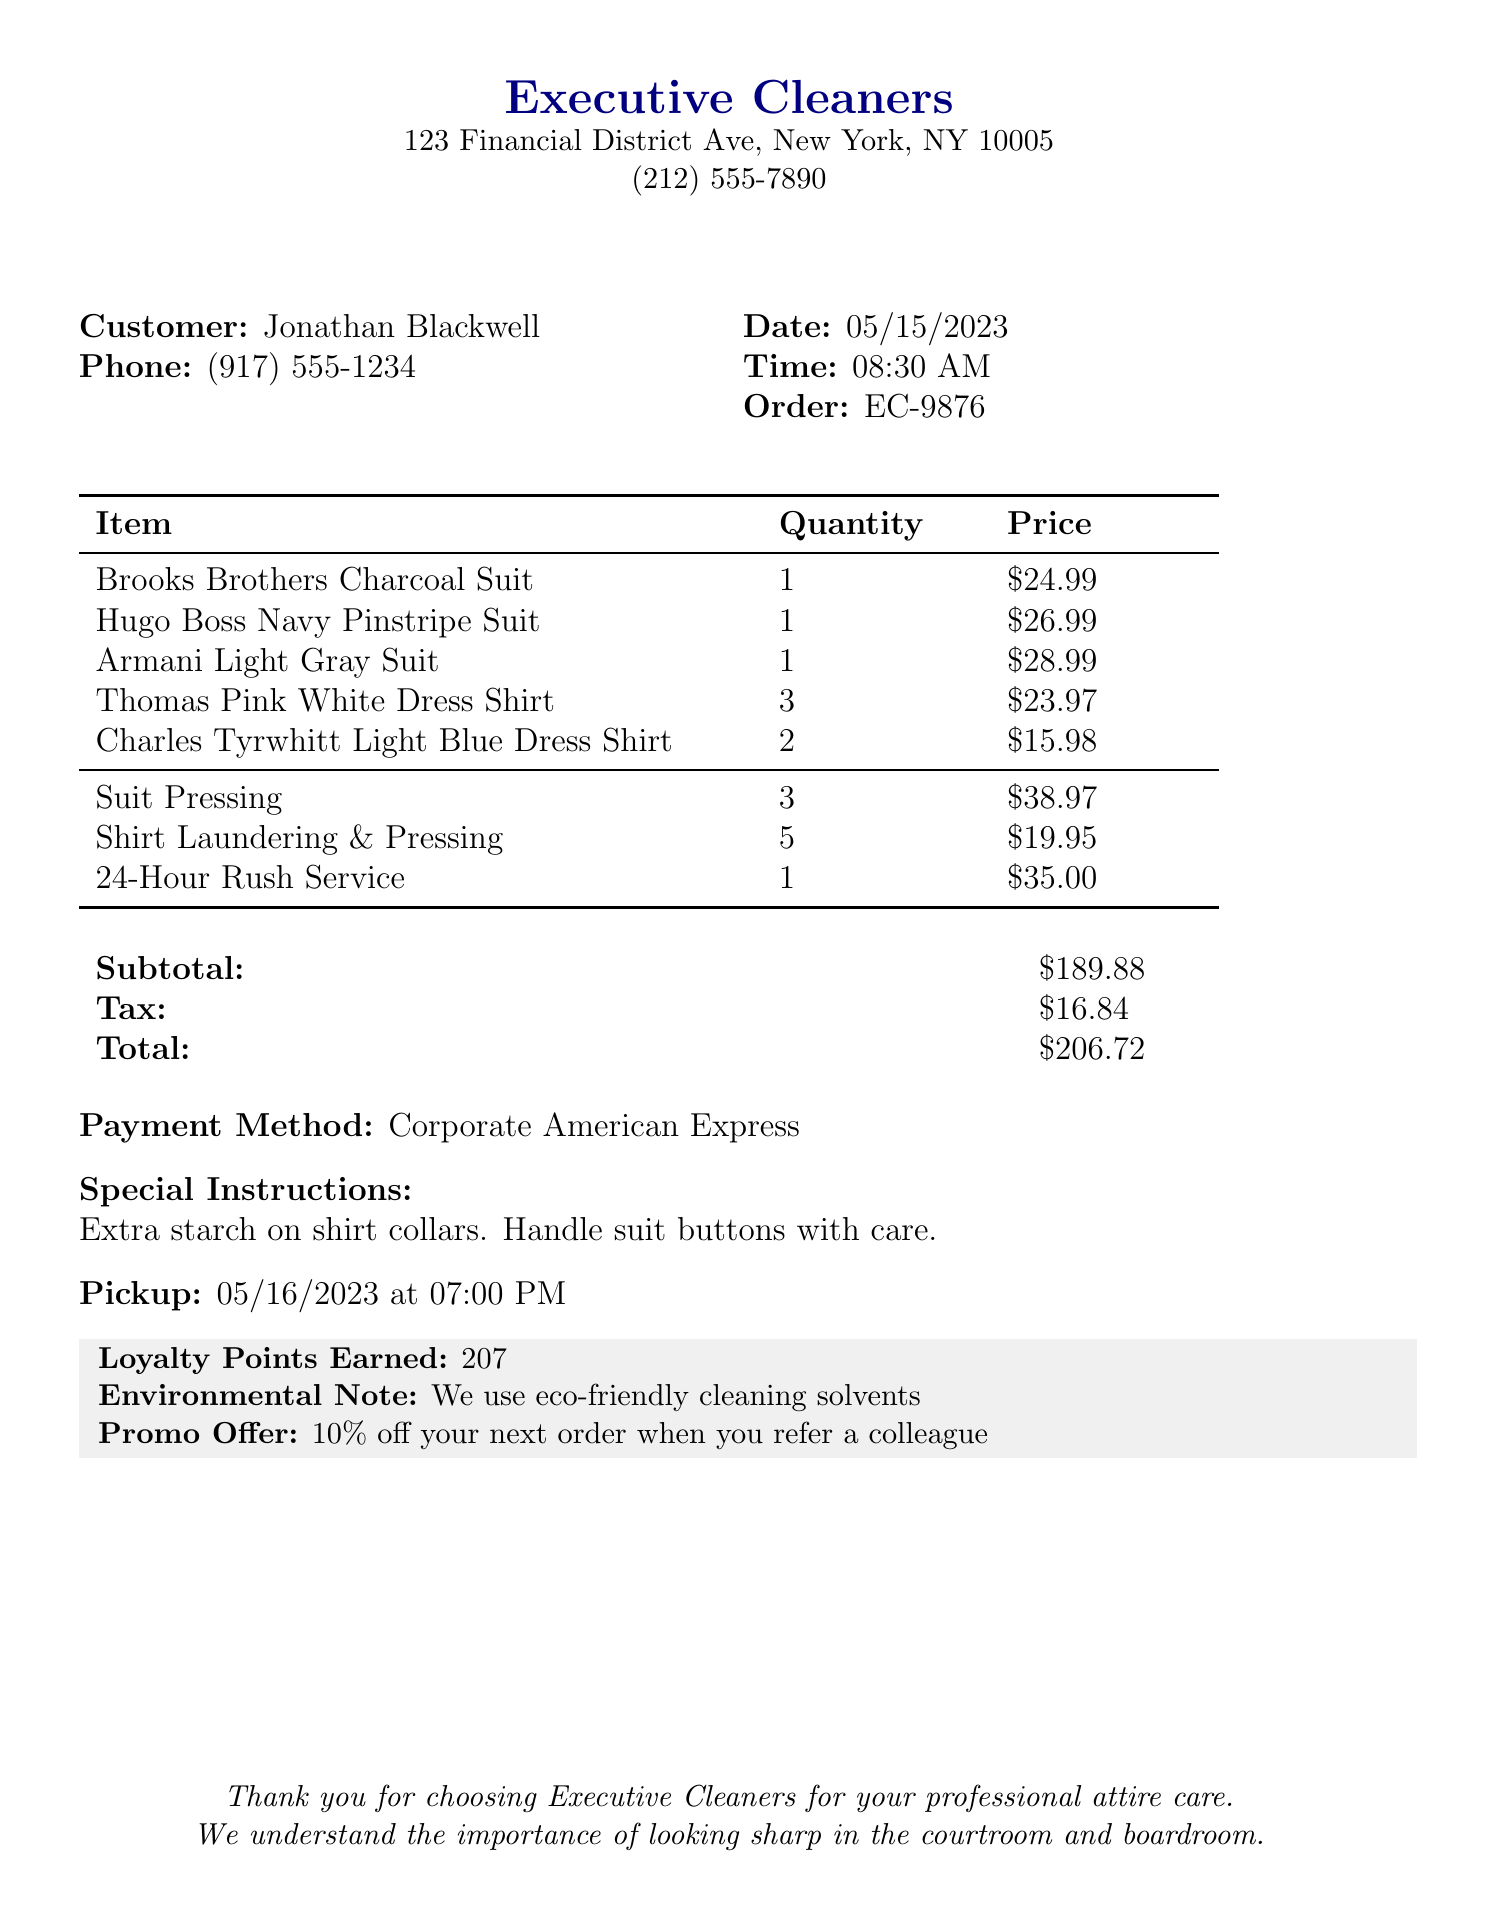What is the business name? The business name is located at the top of the document as the title.
Answer: Executive Cleaners What is the order number? The order number is mentioned in the customer details section of the receipt.
Answer: EC-9876 How many dress shirts are included in the order? The quantity of dress shirts can be found in the itemized list.
Answer: 5 What is the total cost of the order? The total is calculated and displayed at the bottom of the receipt.
Answer: 206.72 How much is the rush service charge? The rush service fee is detailed as a separate item in the services section.
Answer: 35.00 When is the pickup date for the order? The pickup date is stated clearly toward the end of the document.
Answer: 2023-05-16 What special instructions are provided? Special instructions are noted after the payment method in the document.
Answer: Extra starch on shirt collars. Handle suit buttons with care How many loyalty points were earned? Loyalty points are noted in the special section at the bottom of the receipt.
Answer: 207 What is the address of the business? The address can be found directly below the business name at the top.
Answer: 123 Financial District Ave, New York, NY 10005 